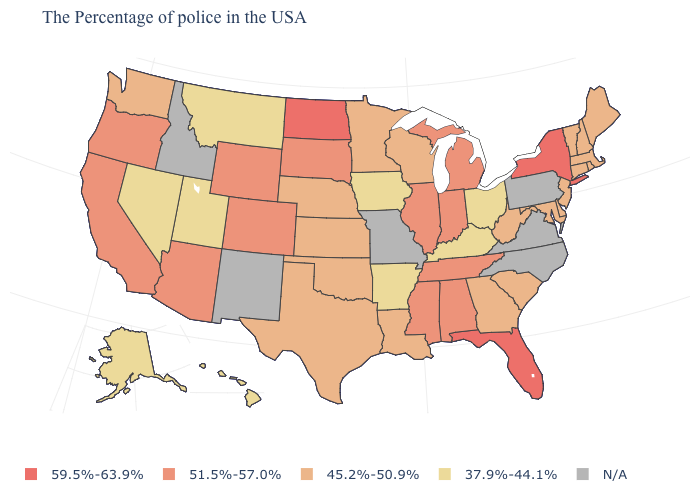Does the first symbol in the legend represent the smallest category?
Answer briefly. No. What is the value of Rhode Island?
Keep it brief. 45.2%-50.9%. What is the value of North Carolina?
Be succinct. N/A. What is the lowest value in the USA?
Keep it brief. 37.9%-44.1%. Does the map have missing data?
Be succinct. Yes. Name the states that have a value in the range 51.5%-57.0%?
Quick response, please. Michigan, Indiana, Alabama, Tennessee, Illinois, Mississippi, South Dakota, Wyoming, Colorado, Arizona, California, Oregon. What is the value of Louisiana?
Quick response, please. 45.2%-50.9%. What is the value of Maryland?
Concise answer only. 45.2%-50.9%. Name the states that have a value in the range 45.2%-50.9%?
Answer briefly. Maine, Massachusetts, Rhode Island, New Hampshire, Vermont, Connecticut, New Jersey, Delaware, Maryland, South Carolina, West Virginia, Georgia, Wisconsin, Louisiana, Minnesota, Kansas, Nebraska, Oklahoma, Texas, Washington. What is the highest value in the USA?
Quick response, please. 59.5%-63.9%. Does Ohio have the lowest value in the USA?
Keep it brief. Yes. Is the legend a continuous bar?
Short answer required. No. Among the states that border Georgia , which have the highest value?
Quick response, please. Florida. 